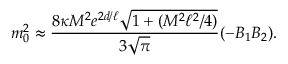Convert formula to latex. <formula><loc_0><loc_0><loc_500><loc_500>m _ { 0 } ^ { 2 } \approx { \frac { 8 \kappa M ^ { 2 } e ^ { 2 d / \ell } \sqrt { 1 + ( M ^ { 2 } \ell ^ { 2 } / 4 ) } } { 3 \sqrt { \pi } } } ( - B _ { 1 } B _ { 2 } ) .</formula> 